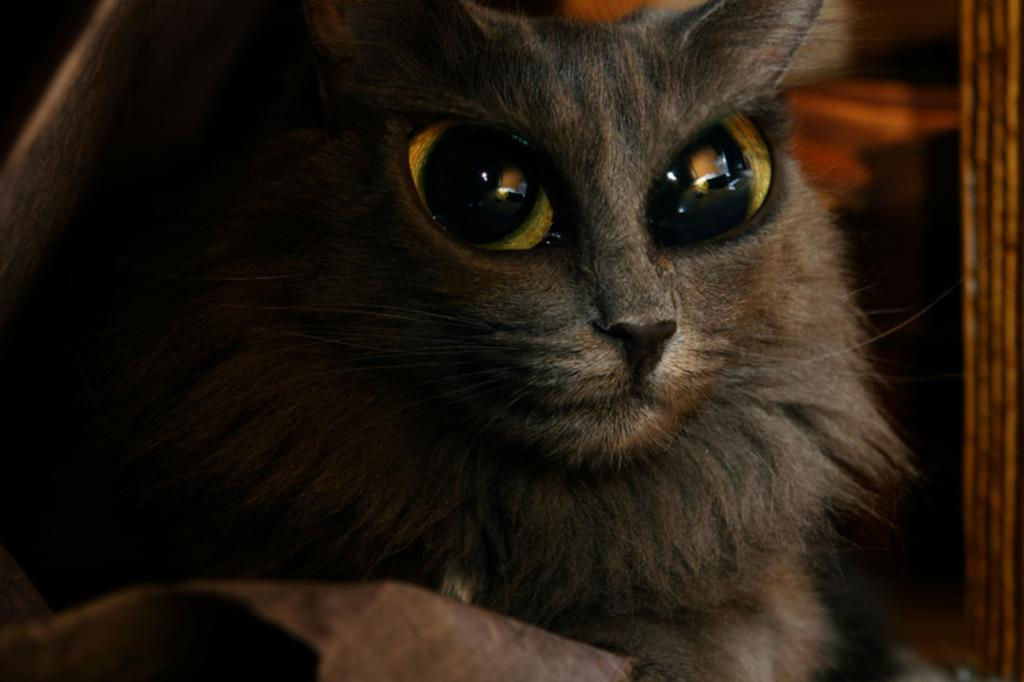What type of animal is present in the image? There is a cat in the image. What type of mask is the cat wearing in the image? There is no mask present in the image; it is a cat without any accessories. 